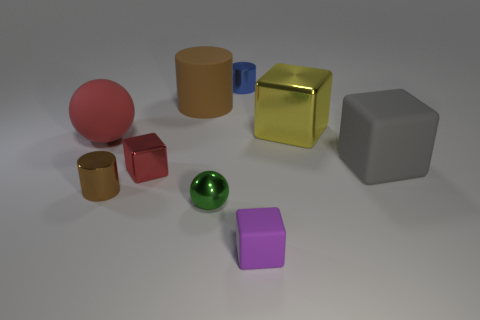What number of cylinders are in front of the metal cube that is in front of the big gray block?
Your response must be concise. 1. How many objects are objects that are to the left of the tiny brown thing or big blue rubber blocks?
Keep it short and to the point. 1. Is there a large green metal thing of the same shape as the large gray thing?
Keep it short and to the point. No. What is the shape of the tiny red thing that is in front of the tiny cylinder that is behind the large rubber cube?
Offer a terse response. Cube. How many cylinders are big things or tiny purple objects?
Make the answer very short. 1. What is the material of the other cylinder that is the same color as the large rubber cylinder?
Provide a succinct answer. Metal. There is a large matte object to the right of the tiny ball; is it the same shape as the big rubber thing behind the big shiny thing?
Make the answer very short. No. There is a tiny metallic thing that is in front of the red metallic object and right of the large brown rubber cylinder; what color is it?
Your answer should be compact. Green. There is a small rubber block; is it the same color as the metal block to the left of the purple rubber thing?
Ensure brevity in your answer.  No. How big is the metal object that is behind the brown shiny object and in front of the big yellow metallic cube?
Your response must be concise. Small. 